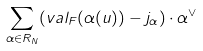<formula> <loc_0><loc_0><loc_500><loc_500>\sum _ { \alpha \in R _ { N } } ( v a l _ { F } ( \alpha ( u ) ) - j _ { \alpha } ) \cdot \alpha ^ { \vee }</formula> 